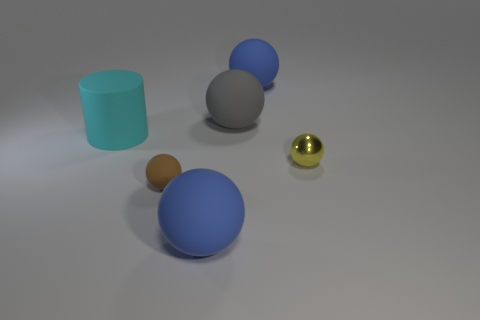How many small objects are either metallic spheres or brown rubber spheres?
Your response must be concise. 2. Are there an equal number of large cyan matte cylinders behind the gray matte sphere and large cyan things in front of the cylinder?
Your answer should be very brief. Yes. How many other things are there of the same color as the small matte object?
Give a very brief answer. 0. Is the color of the large rubber cylinder the same as the tiny object that is in front of the tiny yellow shiny object?
Your answer should be compact. No. How many brown things are either large rubber objects or spheres?
Give a very brief answer. 1. Are there the same number of tiny yellow balls on the right side of the brown rubber object and small cyan objects?
Your answer should be compact. No. Is there anything else that has the same size as the brown matte sphere?
Provide a short and direct response. Yes. What color is the other tiny matte object that is the same shape as the gray rubber thing?
Offer a very short reply. Brown. How many other large rubber things are the same shape as the brown thing?
Ensure brevity in your answer.  3. What number of tiny cyan shiny cylinders are there?
Your answer should be very brief. 0. 